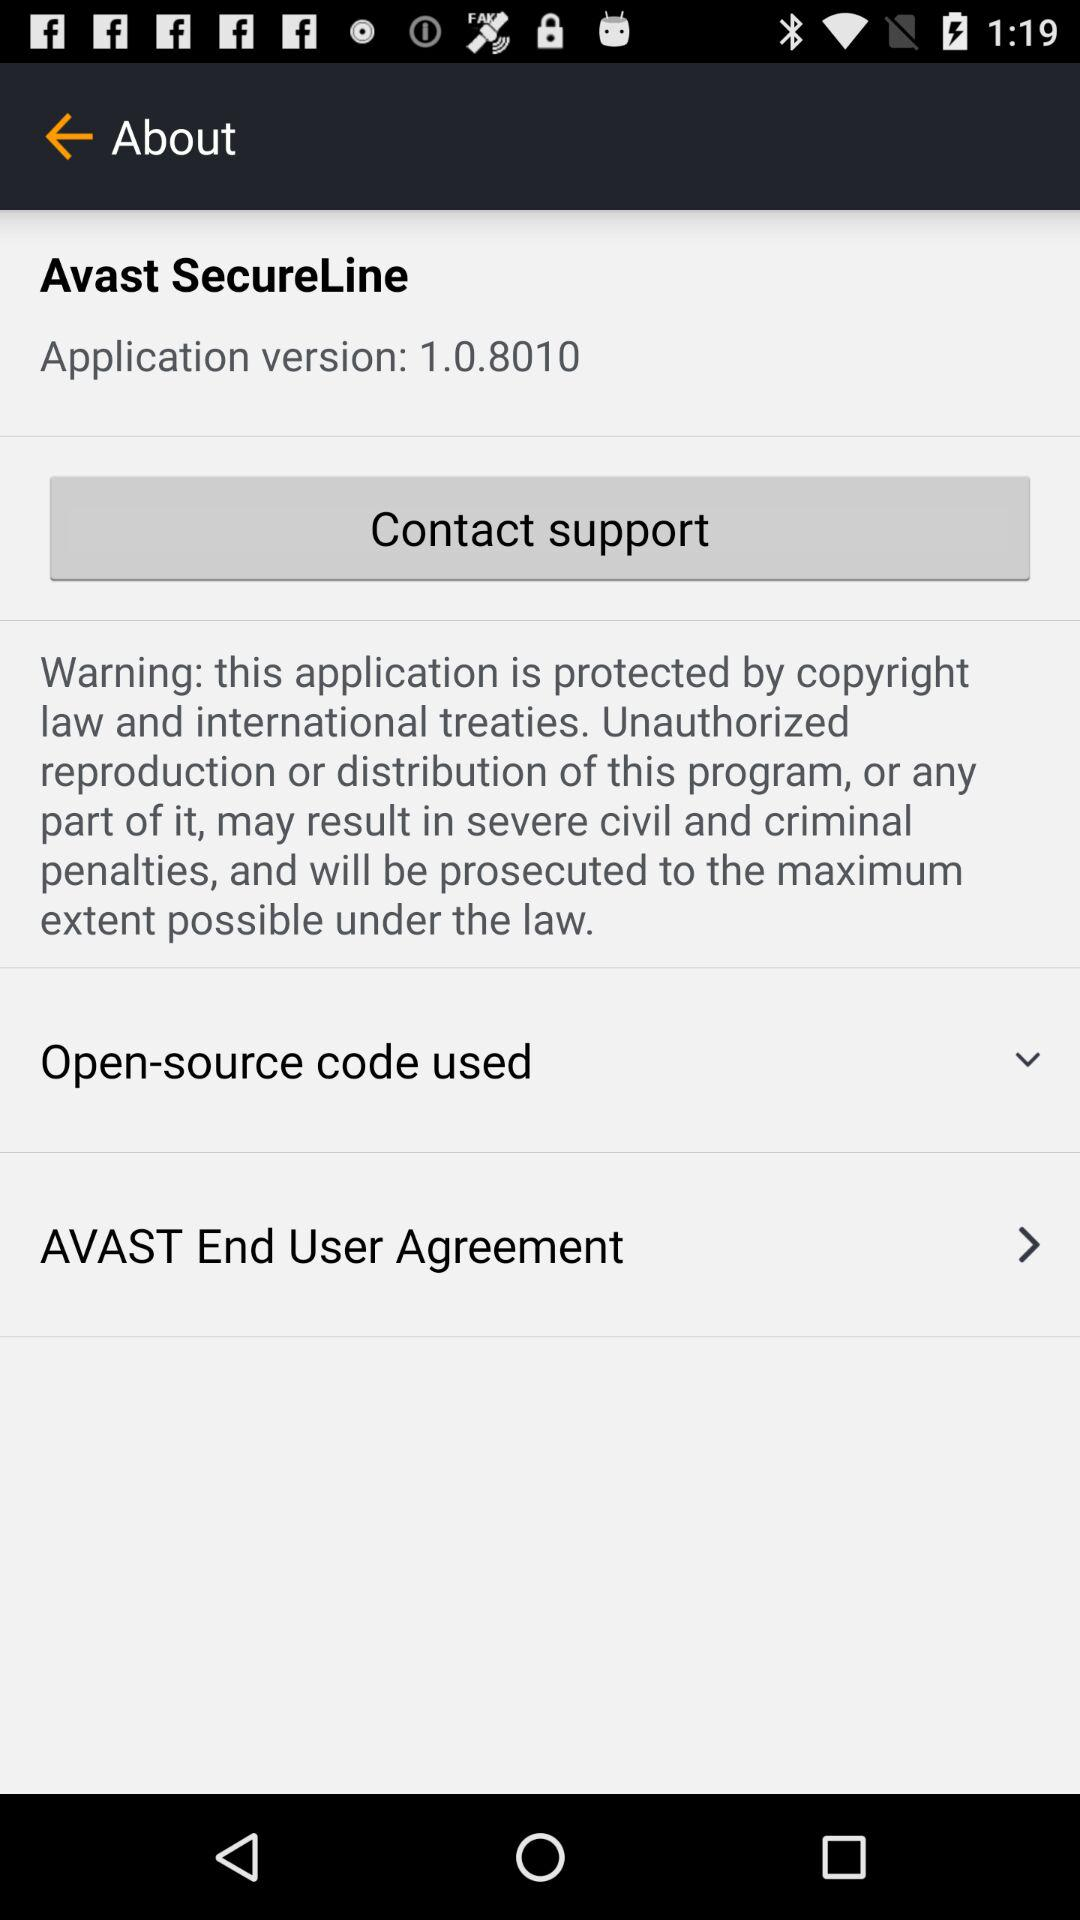Which version of the application is this? The version of the application is 1.0.8010. 